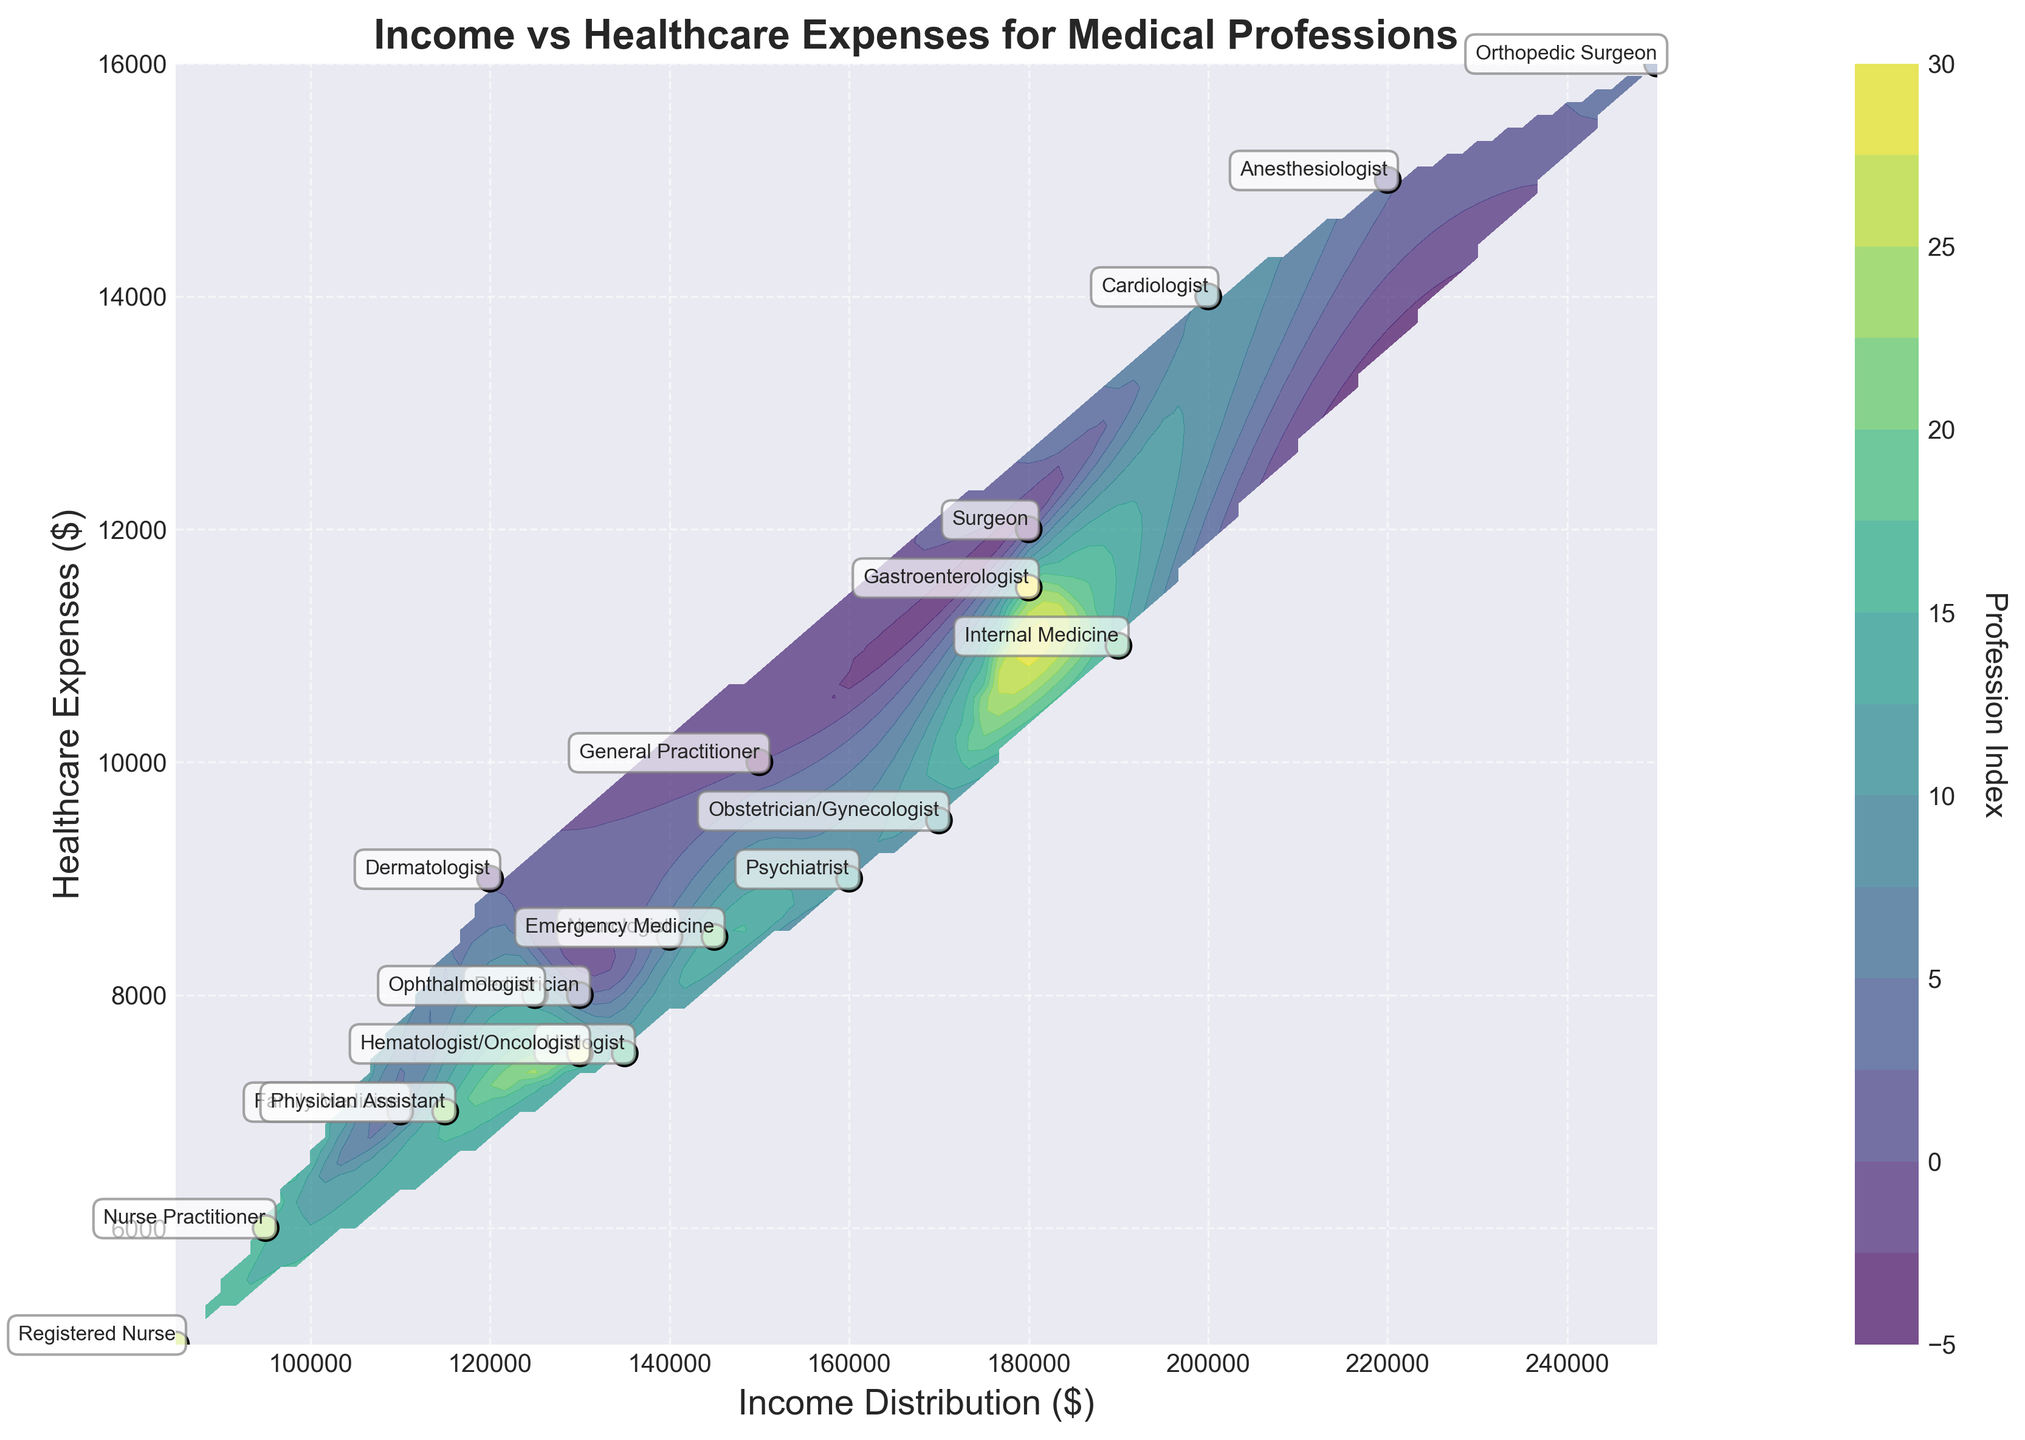What is the title of the figure? The title of the figure is typically placed at the top of the chart. By looking at this position, you can see the text stating the title clearly.
Answer: Income vs Healthcare Expenses for Medical Professions What are the axes labels? Axes labels are positioned along each axis. The x-axis label is at the bottom, and the y-axis label is on the left side. Observing these positions will give you the labels.
Answer: Income Distribution ($) and Healthcare Expenses ($) Which profession has the highest healthcare expenses? The highest healthcare expenses are identified by the highest position on the y-axis. Trace the highest point on the y-axis and check the associated annotation for the profession.
Answer: Orthopedic Surgeon Which profession has the lowest income distribution? The lowest income distribution can be found by identifying the leftmost point along the x-axis. Observing this point and referring to the annotation will reveal the profession.
Answer: Registered Nurse What is the general relationship between income distribution and healthcare expenses for medical professions? By observing the overall trend of the scatter points and the contour lines in relation to the axes, you can infer the relationship. Higher income distributions tend to align with higher healthcare expenses.
Answer: Positive correlation Which profession is closest to the $140,000 income distribution mark? Find the $140,000 mark on the x-axis and locate the scatter point nearest to this value. Then, refer to the annotation for the corresponding profession.
Answer: Neurologist Compare the healthcare expenses of Cardiologists and Gastroenterologists. Locate the positions of Cardiologists and Gastroenterologists in the plot. Cardiologists have expenses at the $14,000 mark while Gastroenterologists have expenses at the $11,500 mark.
Answer: Cardiologists' expenses are higher What's the average healthcare expense across all professions shown? Calculate the average by summing all the healthcare expenses and dividing by the number of professions. The calculation involves adding the listed expenses and dividing by 20.
Answer: $9575 Which profession shows a similar income distribution to Pediatricians but higher healthcare expenses? Locate the scatter point for Pediatricians at $130,000 income and $8,000 expenses. Then, look for another profession around $130,000 but with higher expenses.
Answer: Gastroenterologist Do highly specialized professions tend to have higher income distributions in this plot? Highly specialized professions like Anesthesiologist, Orthopedic Surgeon, Cardiologist, and Gastroenterologist can be observed. These points are generally farther to the right on the x-axis denoting higher income distribution.
Answer: Yes 